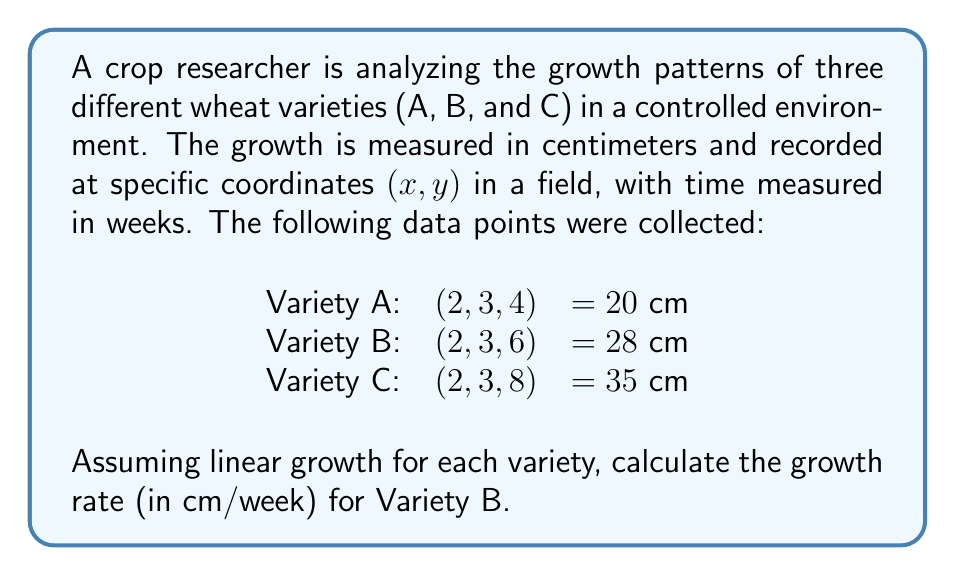Can you answer this question? To solve this problem, we need to analyze the growth pattern of Variety B using the given 3D coordinates (x, y, time) and the corresponding height measurements. We'll follow these steps:

1. Identify the relevant data points:
   Variety B: (2, 3, 6) = 28 cm

2. Since we're asked about the growth rate of Variety B, we need another data point to calculate the rate. We can use the information from Variety A, assuming they start at the same height:
   Variety A: (2, 3, 4) = 20 cm

3. Calculate the change in height:
   $$\Delta \text{height} = 28 \text{ cm} - 20 \text{ cm} = 8 \text{ cm}$$

4. Calculate the change in time:
   $$\Delta \text{time} = 6 \text{ weeks} - 4 \text{ weeks} = 2 \text{ weeks}$$

5. Calculate the growth rate using the formula:
   $$\text{Growth rate} = \frac{\Delta \text{height}}{\Delta \text{time}}$$

   $$\text{Growth rate} = \frac{8 \text{ cm}}{2 \text{ weeks}} = 4 \text{ cm/week}$$

Therefore, the growth rate for Variety B is 4 cm/week.
Answer: 4 cm/week 